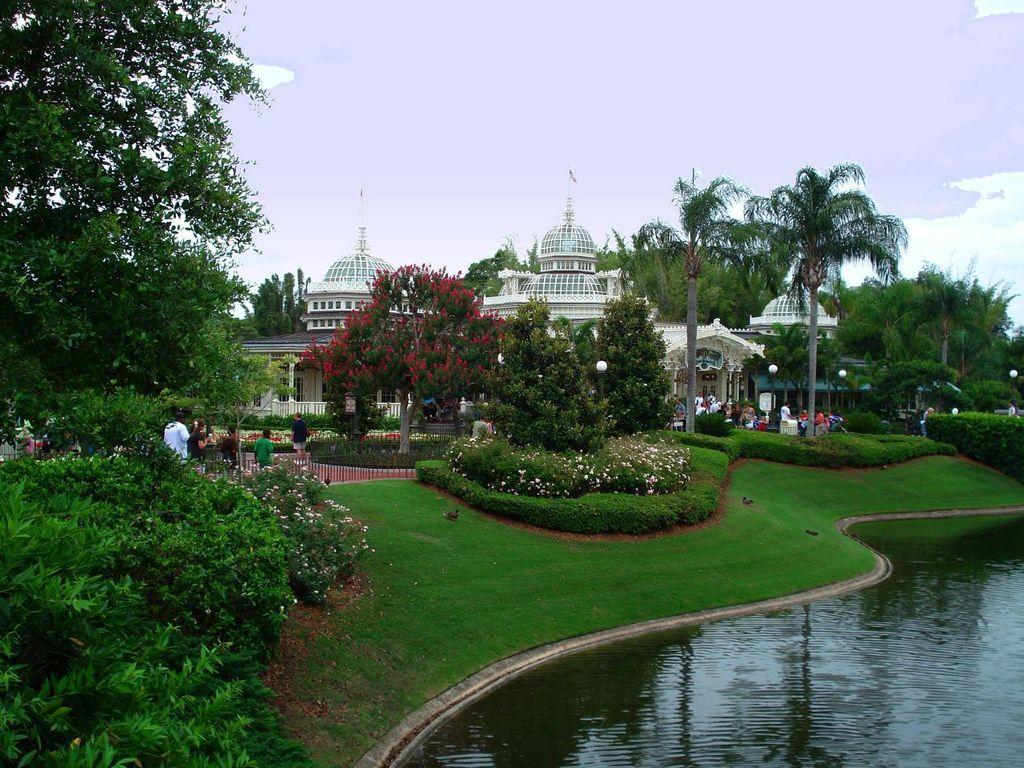Please provide a concise description of this image. Bottom right side of the image there is water. Bottom left side of the image there are some plants and grass. In the middle of the image few people are standing and walking. In the middle of the image there are some trees. Behind the trees there is a building. Top of the image there are some clouds and sky. 